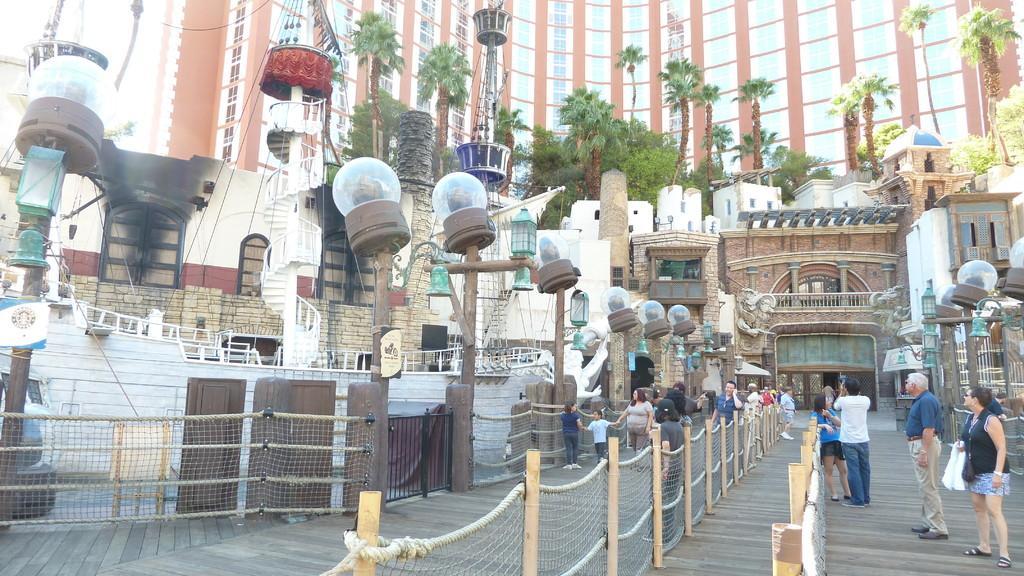Could you give a brief overview of what you see in this image? This image consists of many trees and a building. At the bottom, we can see a fencing made up of ropes and wooden sticks. At the bottom, there is a road. And it looks like a kindergarten. There are many people standing on the road. 